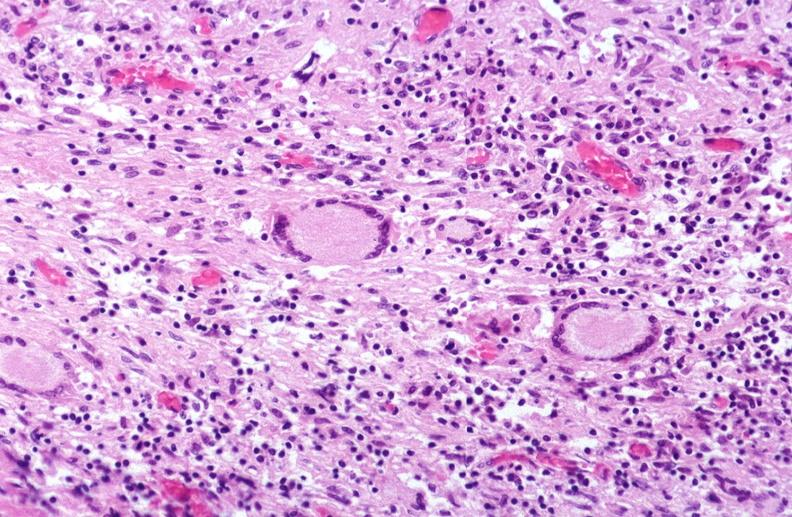what is present?
Answer the question using a single word or phrase. Respiratory 